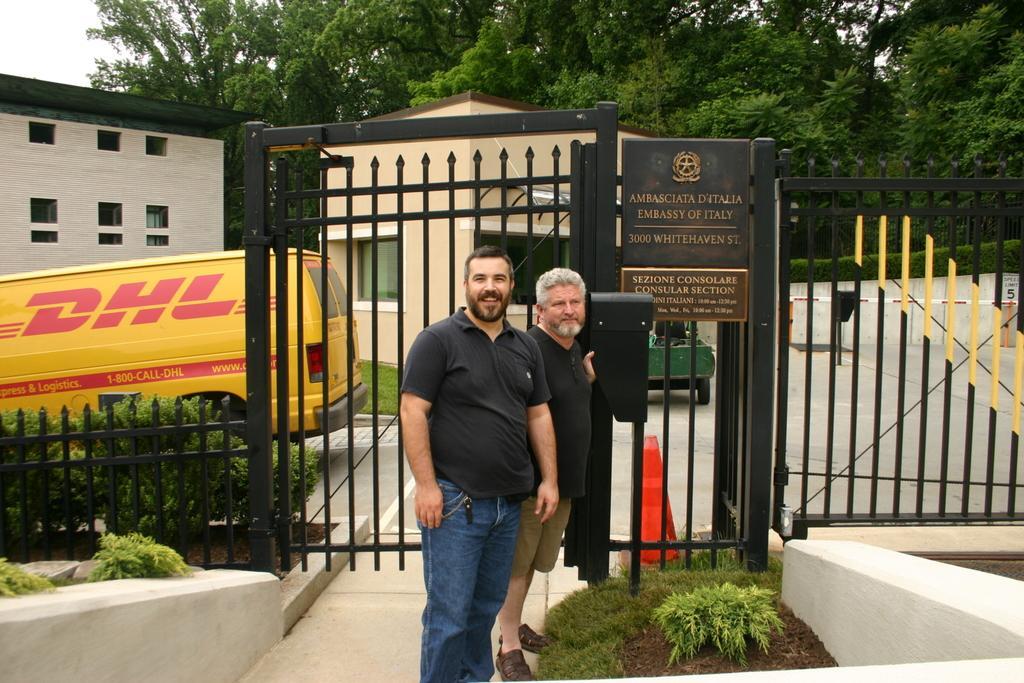Describe this image in one or two sentences. In this image we can see two persons wearing black color T-shirts standing near the gate, there are some plants and in the background of the image there is a vehicle which is in yellow color, there is a house and some trees. 